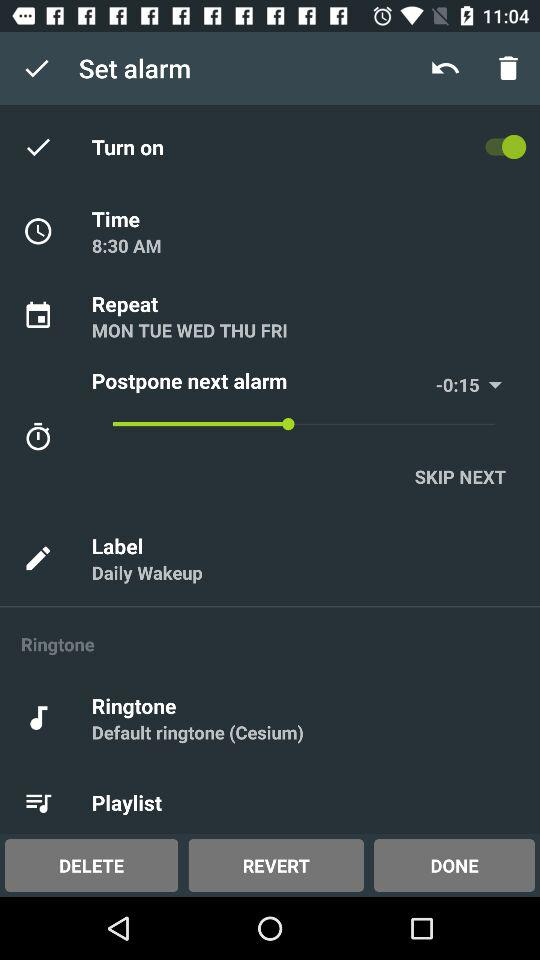For how long will the next alarm duration be delayed?
When the provided information is insufficient, respond with <no answer>. <no answer> 